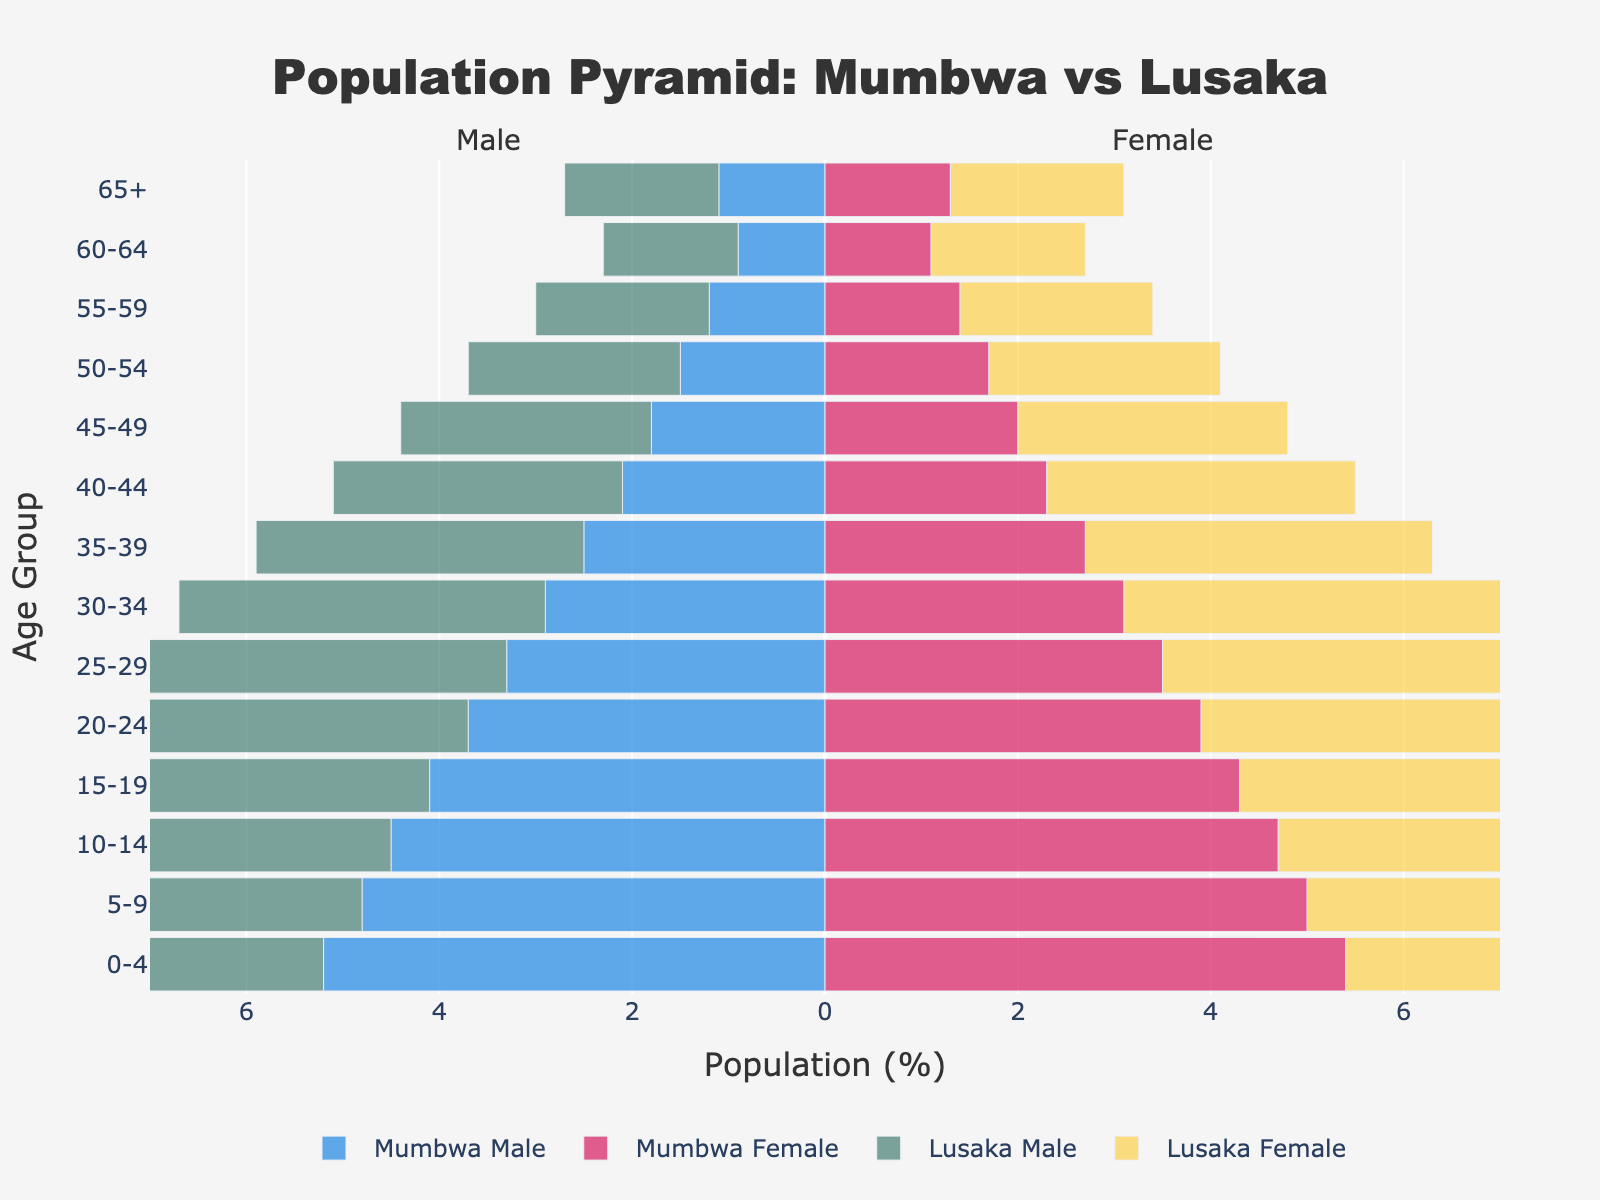What's the title of the figure? The title of the figure is usually positioned at the top center of the chart and is meant to give a summary of what the chart represents. Reading from the chart, the title is "Population Pyramid: Mumbwa vs Lusaka".
Answer: Population Pyramid: Mumbwa vs Lusaka Which city has a higher percentage of males aged 0-4? Compare the lengths of the bars for Mumbwa Male and Lusaka Male in the 0-4 age group. Lusaka Male's bar is longer, indicating a higher percentage.
Answer: Lusaka What age group has the smallest difference between Mumbwa Male and Mumbwa Female? Calculate the absolute differences in percentage points for each age group. The age group with the smallest difference between Mumbwa Male and Mumbwa Female percentages is the '55-59' group (0.2 difference: 1.4 - 1.2).
Answer: 55-59 In the 25-29 age group, what is the percentage difference between Mumbwa Female and Lusaka Female? Subtract the percentage of Mumbwa Female from Lusaka Female for the 25-29 age group. Lusaka Female is 4.4%, Mumbwa Female is 3.5%, so the difference is (4.4 - 3.5).
Answer: 0.9 Which city shows a higher percentage of females in the 65+ age group? Compare the lengths of the bars for Mumbwa Female and Lusaka Female in the 65+ age group. Lusaka Female's bar is longer, indicating a higher percentage.
Answer: Lusaka Which gender has a higher percentage in the 20-24 age group in Mumbwa? Compare the bar lengths for Mumbwa Male and Mumbwa Female in the 20-24 age group. The longer bar represents the higher percentage - in this case, Mumbwa Female is higher at 3.9%.
Answer: Female Is there any age group where the percentages for males and females in Lusaka are the same? Visually inspect the lengths of the bars for Lusaka Male and Lusaka Female in each age group. There is no age group where both have exactly equal percentages.
Answer: No What is the combined percentage of Mumbwa Male and Female in the 30-34 age group? Add the percentages of Mumbwa Male and Mumbwa Female for the 30-34 age group. Mumbwa Male is 2.9% and Mumbwa Female is 3.1%, so the combined percentage is (2.9 + 3.1).
Answer: 6.0 How does the percentage of Lusaka Male in the 45-49 age group compare to Mumbwa Male in the same group? Compare the lengths of the bars for Lusaka Male and Mumbwa Male in the 45-49 age group. Lusaka has a longer bar representing a higher percentage (2.6% vs. 1.8%).
Answer: Lusaka is higher Which city shows a steeper decrease in the male population from the '0-4' to '20-24' age group? Analyze the difference in bar lengths for Mumbwa Male and Lusaka Male between 0-4 and 20-24 age groups. Mumbwa goes from 5.2% to 3.7% (decrease of 1.5%), Lusaka from 6.1% to 4.6% (decrease of 1.5%). Both cities show equal decreases.
Answer: Both cities show equal decreases 